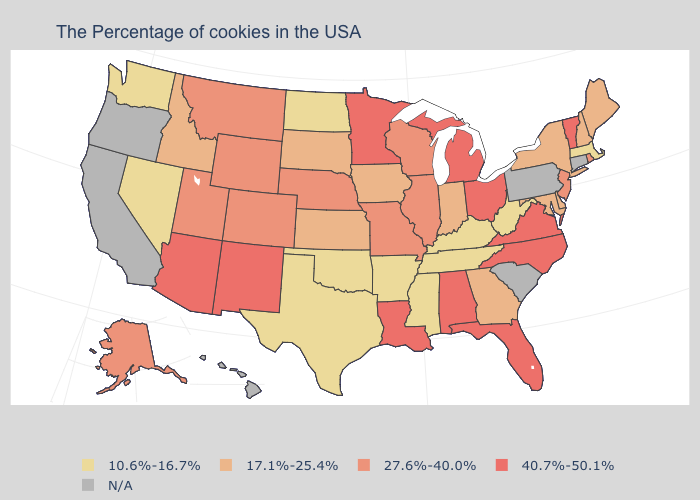Does Michigan have the highest value in the USA?
Quick response, please. Yes. How many symbols are there in the legend?
Quick response, please. 5. What is the highest value in the West ?
Concise answer only. 40.7%-50.1%. Does North Dakota have the lowest value in the MidWest?
Keep it brief. Yes. Does the map have missing data?
Keep it brief. Yes. Which states have the lowest value in the USA?
Keep it brief. Massachusetts, West Virginia, Kentucky, Tennessee, Mississippi, Arkansas, Oklahoma, Texas, North Dakota, Nevada, Washington. What is the value of New Hampshire?
Give a very brief answer. 17.1%-25.4%. What is the highest value in states that border Arizona?
Answer briefly. 40.7%-50.1%. Among the states that border Indiana , does Ohio have the lowest value?
Keep it brief. No. Does Maine have the highest value in the Northeast?
Quick response, please. No. Does Nevada have the lowest value in the West?
Quick response, please. Yes. Among the states that border New Hampshire , which have the lowest value?
Concise answer only. Massachusetts. Name the states that have a value in the range 10.6%-16.7%?
Give a very brief answer. Massachusetts, West Virginia, Kentucky, Tennessee, Mississippi, Arkansas, Oklahoma, Texas, North Dakota, Nevada, Washington. 